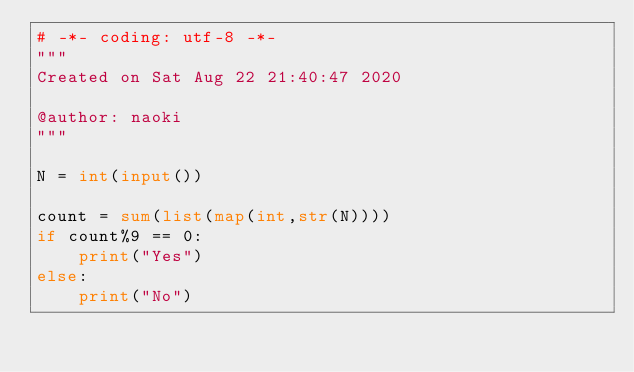Convert code to text. <code><loc_0><loc_0><loc_500><loc_500><_Python_># -*- coding: utf-8 -*-
"""
Created on Sat Aug 22 21:40:47 2020

@author: naoki
"""

N = int(input())

count = sum(list(map(int,str(N))))    
if count%9 == 0:
    print("Yes")
else:
    print("No")</code> 